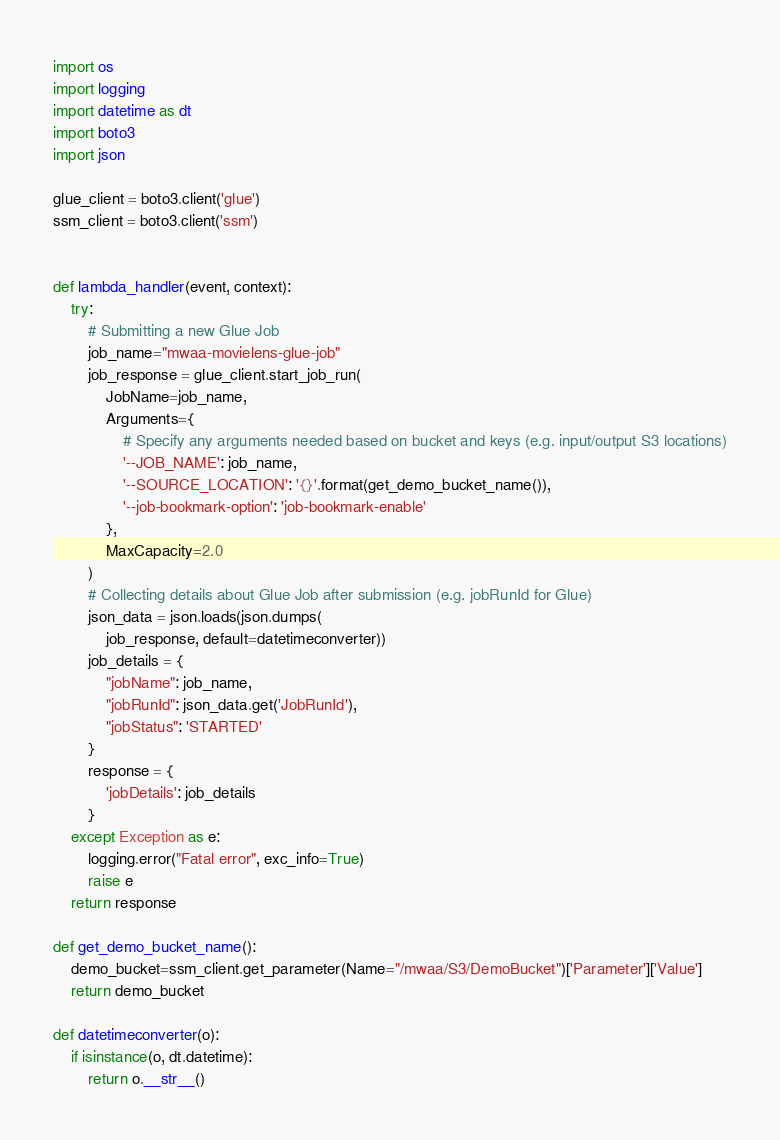<code> <loc_0><loc_0><loc_500><loc_500><_Python_>import os
import logging
import datetime as dt
import boto3
import json

glue_client = boto3.client('glue')
ssm_client = boto3.client('ssm')


def lambda_handler(event, context):
    try:
        # Submitting a new Glue Job
        job_name="mwaa-movielens-glue-job"
        job_response = glue_client.start_job_run(
            JobName=job_name,
            Arguments={
                # Specify any arguments needed based on bucket and keys (e.g. input/output S3 locations)
                '--JOB_NAME': job_name,
                '--SOURCE_LOCATION': '{}'.format(get_demo_bucket_name()),
                '--job-bookmark-option': 'job-bookmark-enable'
            },
            MaxCapacity=2.0
        )
        # Collecting details about Glue Job after submission (e.g. jobRunId for Glue)
        json_data = json.loads(json.dumps(
            job_response, default=datetimeconverter))
        job_details = {
            "jobName": job_name,
            "jobRunId": json_data.get('JobRunId'),
            "jobStatus": 'STARTED'
        }
        response = {
            'jobDetails': job_details
        }
    except Exception as e:
        logging.error("Fatal error", exc_info=True)
        raise e
    return response

def get_demo_bucket_name():
    demo_bucket=ssm_client.get_parameter(Name="/mwaa/S3/DemoBucket")['Parameter']['Value']
    return demo_bucket

def datetimeconverter(o):
    if isinstance(o, dt.datetime):
        return o.__str__()
</code> 